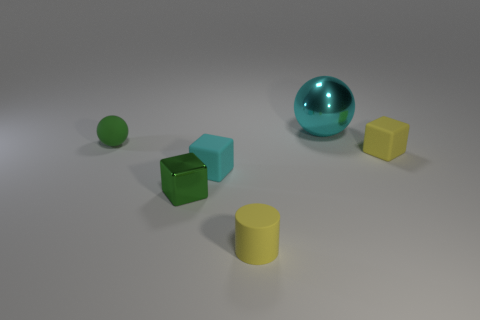Add 3 yellow cylinders. How many objects exist? 9 Subtract all cylinders. How many objects are left? 5 Subtract all tiny purple shiny blocks. Subtract all yellow rubber cubes. How many objects are left? 5 Add 1 small green blocks. How many small green blocks are left? 2 Add 6 green matte things. How many green matte things exist? 7 Subtract 0 brown cylinders. How many objects are left? 6 